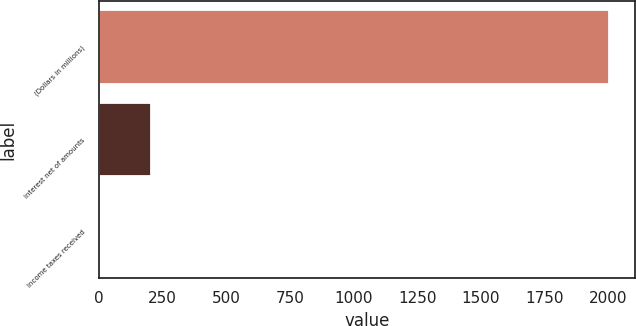Convert chart. <chart><loc_0><loc_0><loc_500><loc_500><bar_chart><fcel>(Dollars in millions)<fcel>Interest net of amounts<fcel>Income taxes received<nl><fcel>2004<fcel>203.1<fcel>3<nl></chart> 